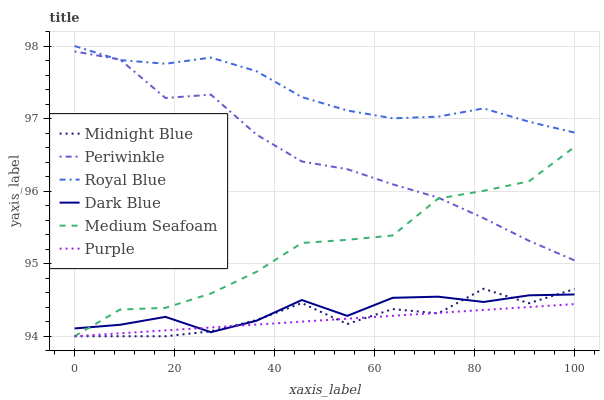Does Purple have the minimum area under the curve?
Answer yes or no. Yes. Does Royal Blue have the maximum area under the curve?
Answer yes or no. Yes. Does Dark Blue have the minimum area under the curve?
Answer yes or no. No. Does Dark Blue have the maximum area under the curve?
Answer yes or no. No. Is Purple the smoothest?
Answer yes or no. Yes. Is Midnight Blue the roughest?
Answer yes or no. Yes. Is Dark Blue the smoothest?
Answer yes or no. No. Is Dark Blue the roughest?
Answer yes or no. No. Does Midnight Blue have the lowest value?
Answer yes or no. Yes. Does Dark Blue have the lowest value?
Answer yes or no. No. Does Royal Blue have the highest value?
Answer yes or no. Yes. Does Dark Blue have the highest value?
Answer yes or no. No. Is Midnight Blue less than Periwinkle?
Answer yes or no. Yes. Is Periwinkle greater than Purple?
Answer yes or no. Yes. Does Medium Seafoam intersect Dark Blue?
Answer yes or no. Yes. Is Medium Seafoam less than Dark Blue?
Answer yes or no. No. Is Medium Seafoam greater than Dark Blue?
Answer yes or no. No. Does Midnight Blue intersect Periwinkle?
Answer yes or no. No. 